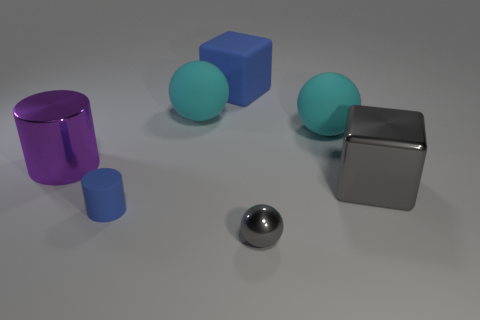Subtract all tiny gray balls. How many balls are left? 2 Subtract all yellow blocks. How many cyan balls are left? 2 Add 3 big purple matte things. How many objects exist? 10 Subtract all purple balls. Subtract all gray cylinders. How many balls are left? 3 Subtract all balls. How many objects are left? 4 Add 4 metal blocks. How many metal blocks exist? 5 Subtract 0 red balls. How many objects are left? 7 Subtract all cylinders. Subtract all large blue cubes. How many objects are left? 4 Add 3 tiny matte cylinders. How many tiny matte cylinders are left? 4 